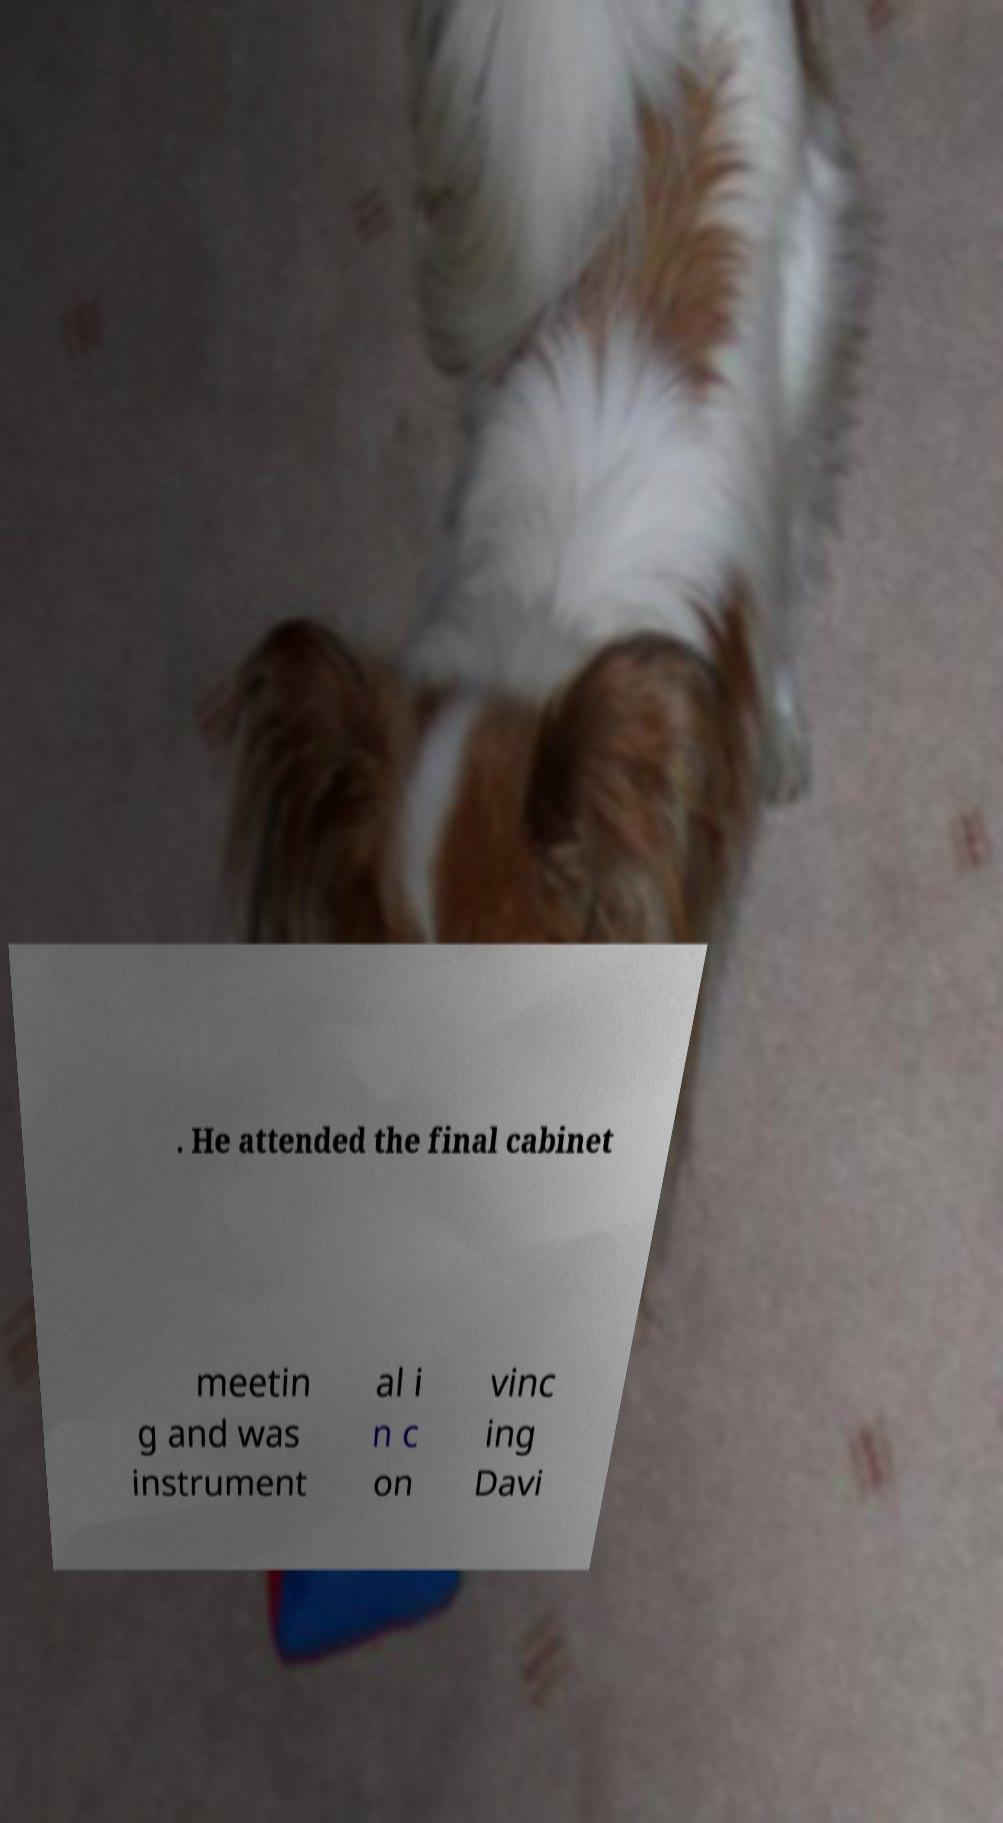What messages or text are displayed in this image? I need them in a readable, typed format. . He attended the final cabinet meetin g and was instrument al i n c on vinc ing Davi 